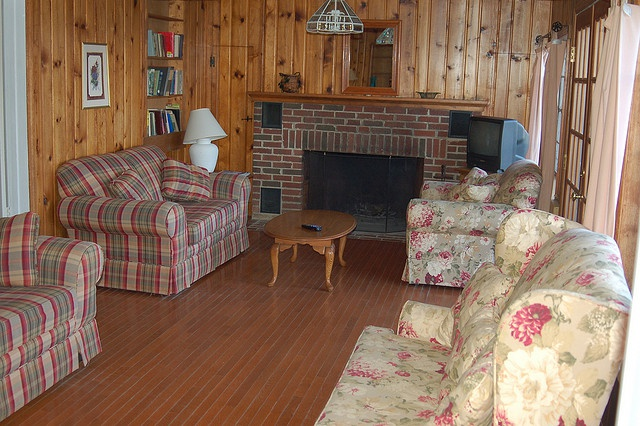Describe the objects in this image and their specific colors. I can see chair in darkgray, tan, and beige tones, couch in darkgray, tan, and beige tones, couch in darkgray, gray, and maroon tones, couch in darkgray, brown, and gray tones, and chair in darkgray and gray tones in this image. 